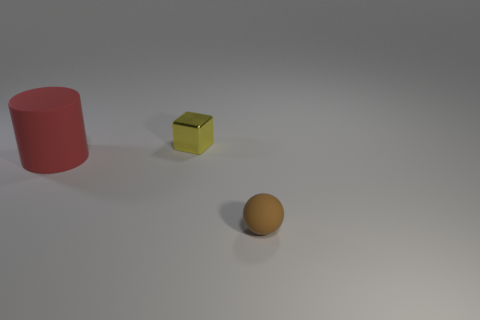There is a tiny object in front of the cylinder; is its shape the same as the matte thing on the left side of the tiny brown ball?
Offer a very short reply. No. Are there any tiny yellow blocks that have the same material as the red cylinder?
Provide a succinct answer. No. How many brown things are shiny things or large things?
Your answer should be compact. 0. There is a object that is in front of the tiny yellow block and behind the small ball; what is its size?
Provide a succinct answer. Large. Are there more red rubber objects in front of the small rubber sphere than big red cylinders?
Keep it short and to the point. No. How many spheres are either yellow objects or brown objects?
Offer a terse response. 1. There is a thing that is both on the left side of the ball and in front of the tiny metallic block; what is its shape?
Ensure brevity in your answer.  Cylinder. Are there an equal number of red cylinders that are in front of the sphere and brown balls that are in front of the red thing?
Give a very brief answer. No. How many things are tiny brown things or big red metallic things?
Provide a succinct answer. 1. The other rubber object that is the same size as the yellow thing is what color?
Provide a short and direct response. Brown. 